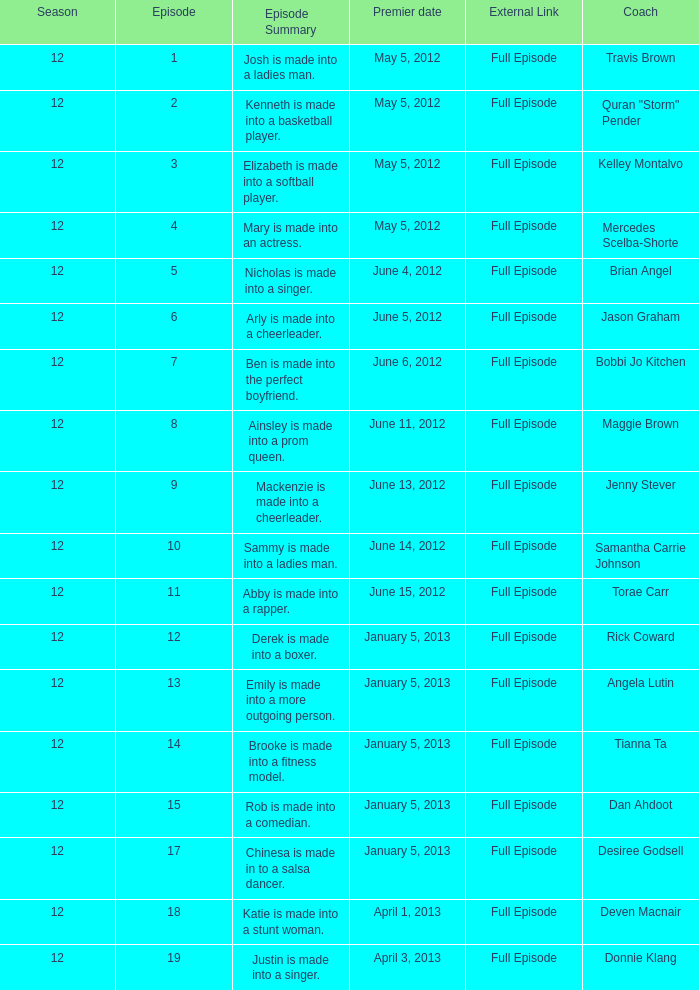Name the episode summary for torae carr Abby is made into a rapper. 